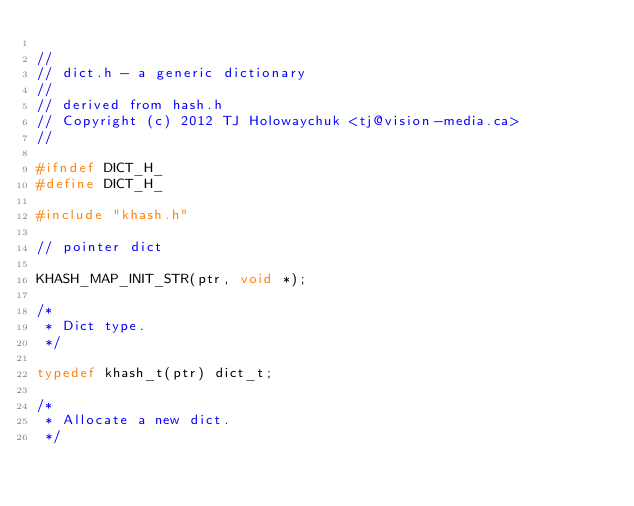<code> <loc_0><loc_0><loc_500><loc_500><_C_>
//
// dict.h - a generic dictionary
//
// derived from hash.h
// Copyright (c) 2012 TJ Holowaychuk <tj@vision-media.ca>
//

#ifndef DICT_H_
#define DICT_H_

#include "khash.h"

// pointer dict

KHASH_MAP_INIT_STR(ptr, void *);

/*
 * Dict type.
 */

typedef khash_t(ptr) dict_t;

/*
 * Allocate a new dict.
 */
</code> 